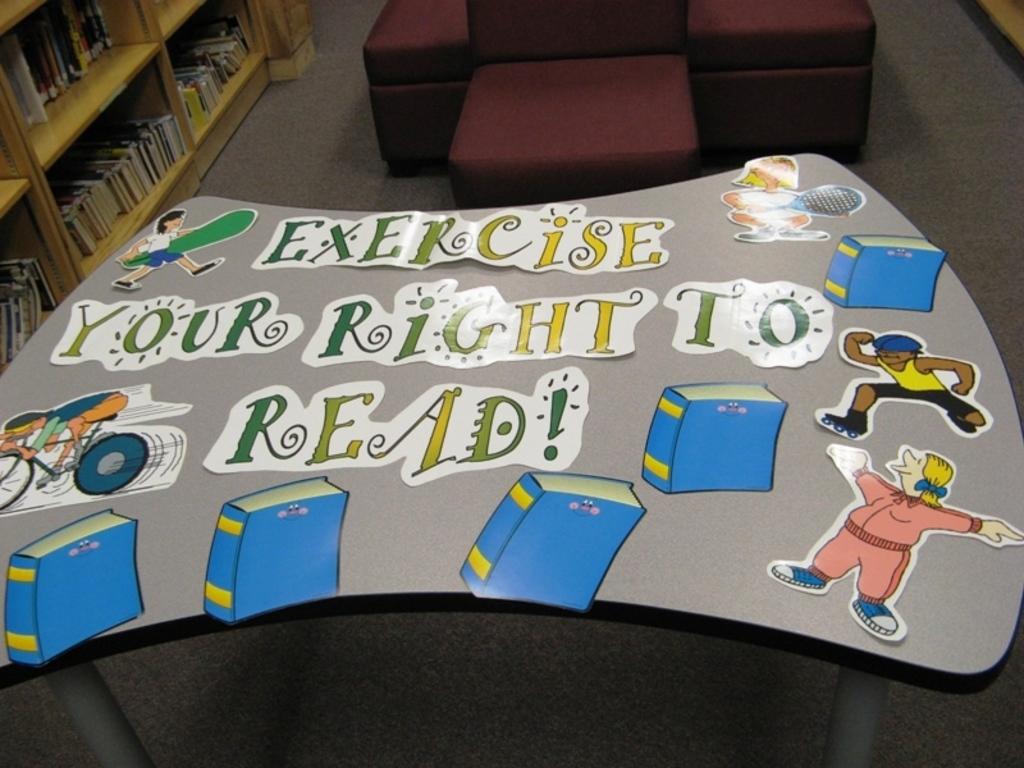What is the last word on the table?
Ensure brevity in your answer.  Read. 